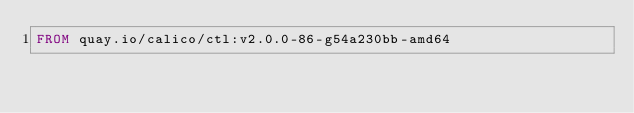Convert code to text. <code><loc_0><loc_0><loc_500><loc_500><_Dockerfile_>FROM quay.io/calico/ctl:v2.0.0-86-g54a230bb-amd64
</code> 